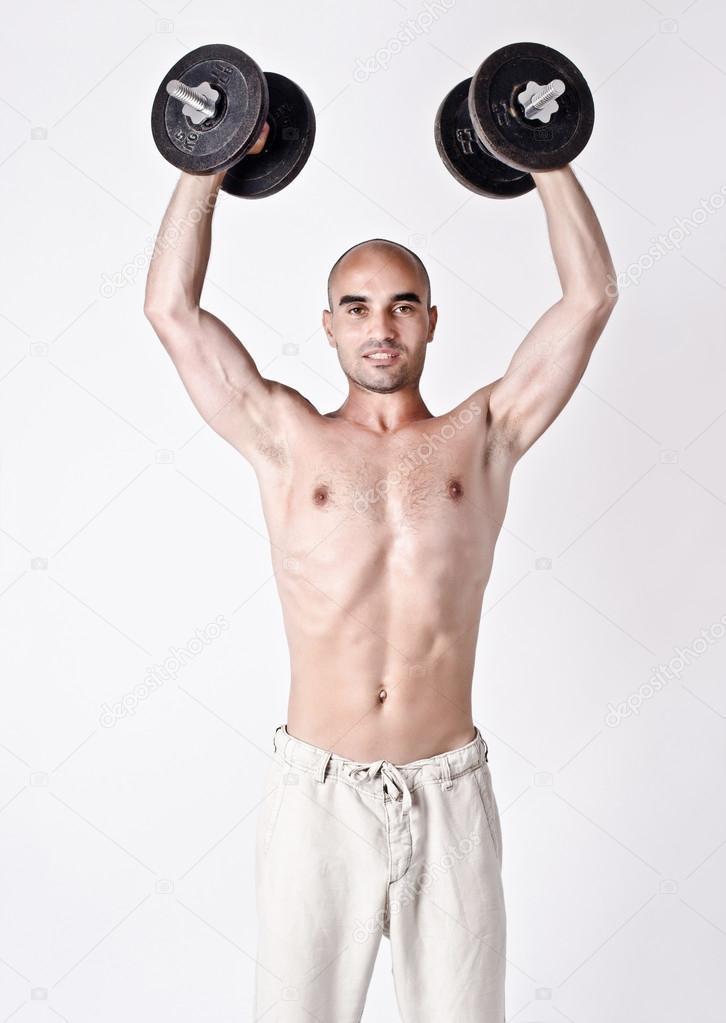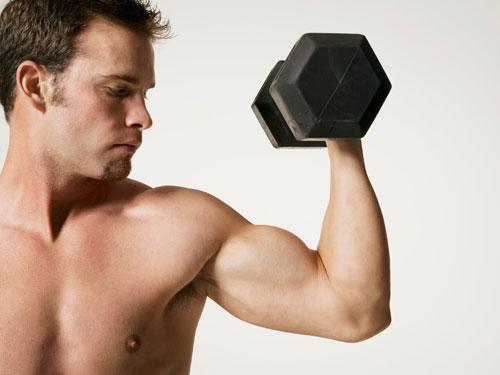The first image is the image on the left, the second image is the image on the right. Assess this claim about the two images: "An image shows a man holding identical weights in each hand.". Correct or not? Answer yes or no. Yes. 